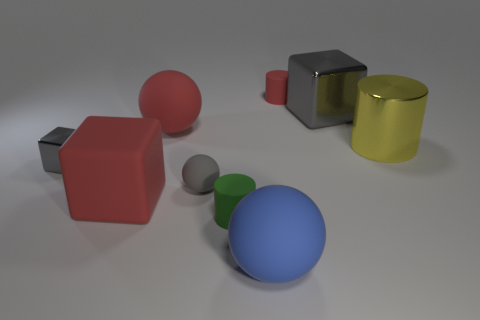There is a small block that is the same color as the tiny matte sphere; what is it made of?
Your response must be concise. Metal. What color is the metal block that is the same size as the red matte cylinder?
Provide a succinct answer. Gray. Is there anything else that has the same shape as the green object?
Make the answer very short. Yes. There is another metallic thing that is the same shape as the small red object; what color is it?
Your answer should be very brief. Yellow. What number of objects are either small gray matte objects or small things that are right of the large red cube?
Your answer should be very brief. 3. Are there fewer small green objects that are right of the green thing than small cyan metal balls?
Your answer should be compact. No. What size is the cube behind the gray metallic object that is on the left side of the red thing on the right side of the large blue object?
Offer a very short reply. Large. There is a big object that is on the left side of the tiny green matte cylinder and behind the big yellow metallic cylinder; what color is it?
Your response must be concise. Red. How many large yellow balls are there?
Ensure brevity in your answer.  0. Is there anything else that has the same size as the rubber cube?
Offer a terse response. Yes. 